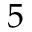Convert formula to latex. <formula><loc_0><loc_0><loc_500><loc_500>5</formula> 